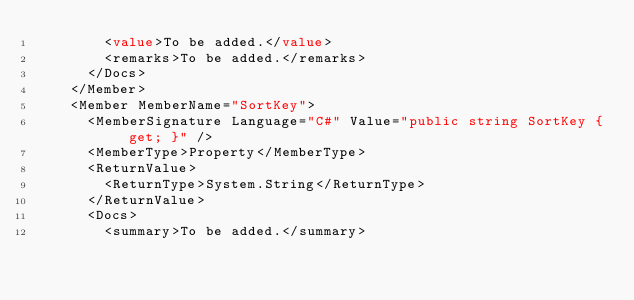Convert code to text. <code><loc_0><loc_0><loc_500><loc_500><_XML_>        <value>To be added.</value>
        <remarks>To be added.</remarks>
      </Docs>
    </Member>
    <Member MemberName="SortKey">
      <MemberSignature Language="C#" Value="public string SortKey { get; }" />
      <MemberType>Property</MemberType>
      <ReturnValue>
        <ReturnType>System.String</ReturnType>
      </ReturnValue>
      <Docs>
        <summary>To be added.</summary></code> 